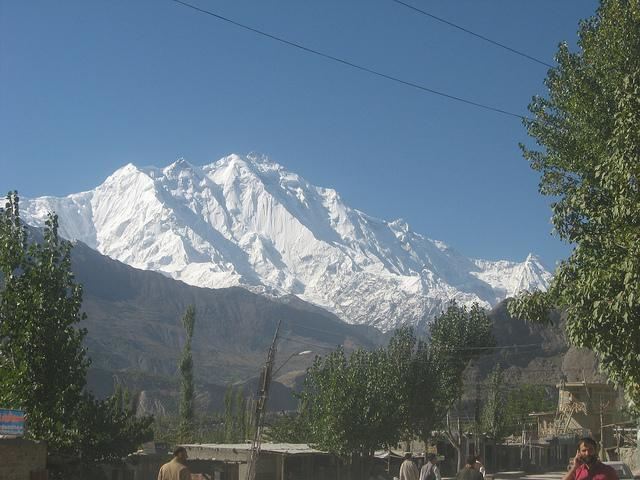Why is there snow up there? Please explain your reasoning. high altitude. The mountains appear quite tall and mountains at this height are known to have snow at the top 